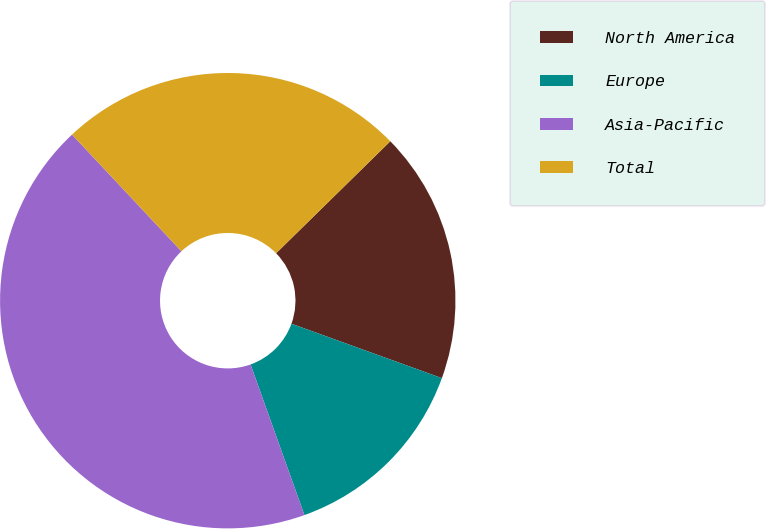Convert chart to OTSL. <chart><loc_0><loc_0><loc_500><loc_500><pie_chart><fcel>North America<fcel>Europe<fcel>Asia-Pacific<fcel>Total<nl><fcel>17.87%<fcel>14.01%<fcel>43.48%<fcel>24.64%<nl></chart> 